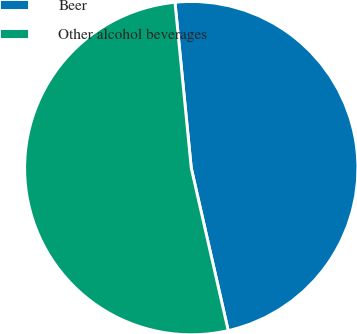Convert chart. <chart><loc_0><loc_0><loc_500><loc_500><pie_chart><fcel>Beer<fcel>Other alcohol beverages<nl><fcel>48.0%<fcel>52.0%<nl></chart> 